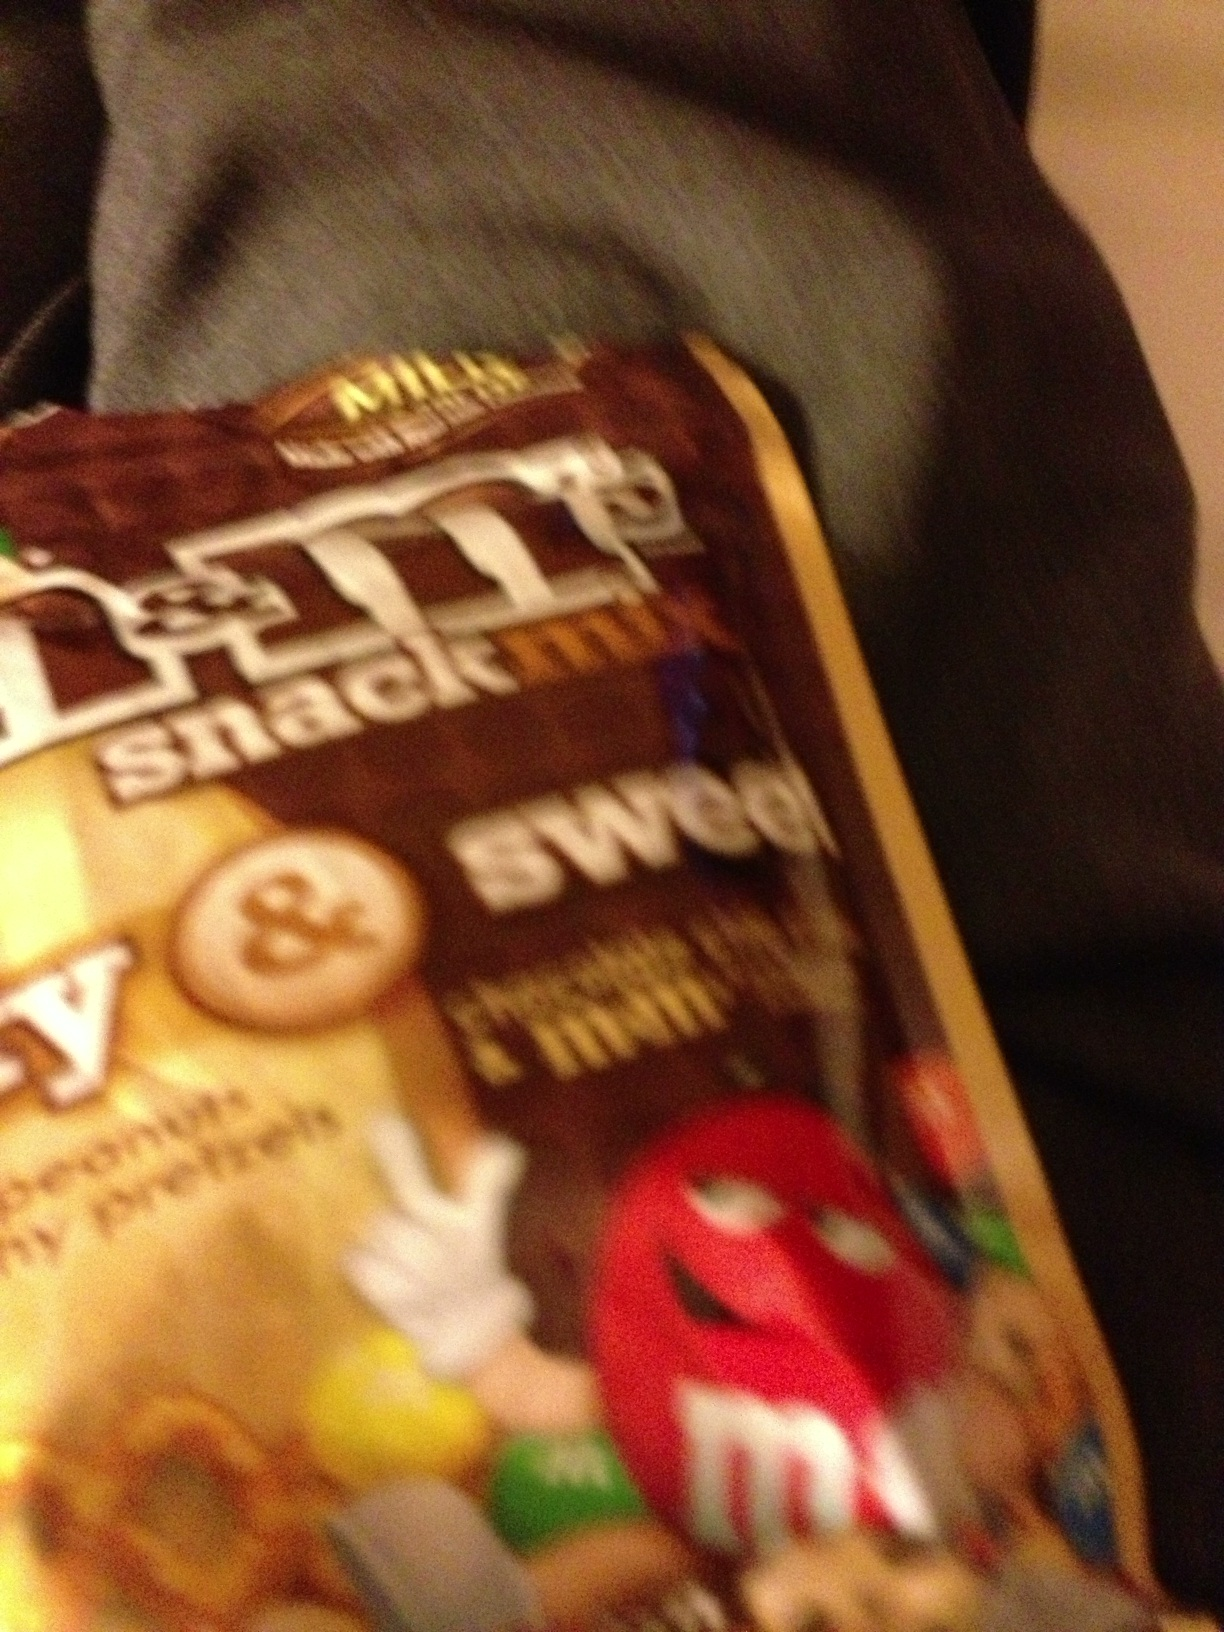What is this picture? from Vizwiz This picture shows a blurry image of a bag of M&Ms snack mix. The product combines M&Ms with other sweet and salty snack items, offering a variety of textures and flavors in one convenient package. The visibility of the red M&M character suggests that this is a promotional or branded item aimed at appealing to fans of M&Ms. 